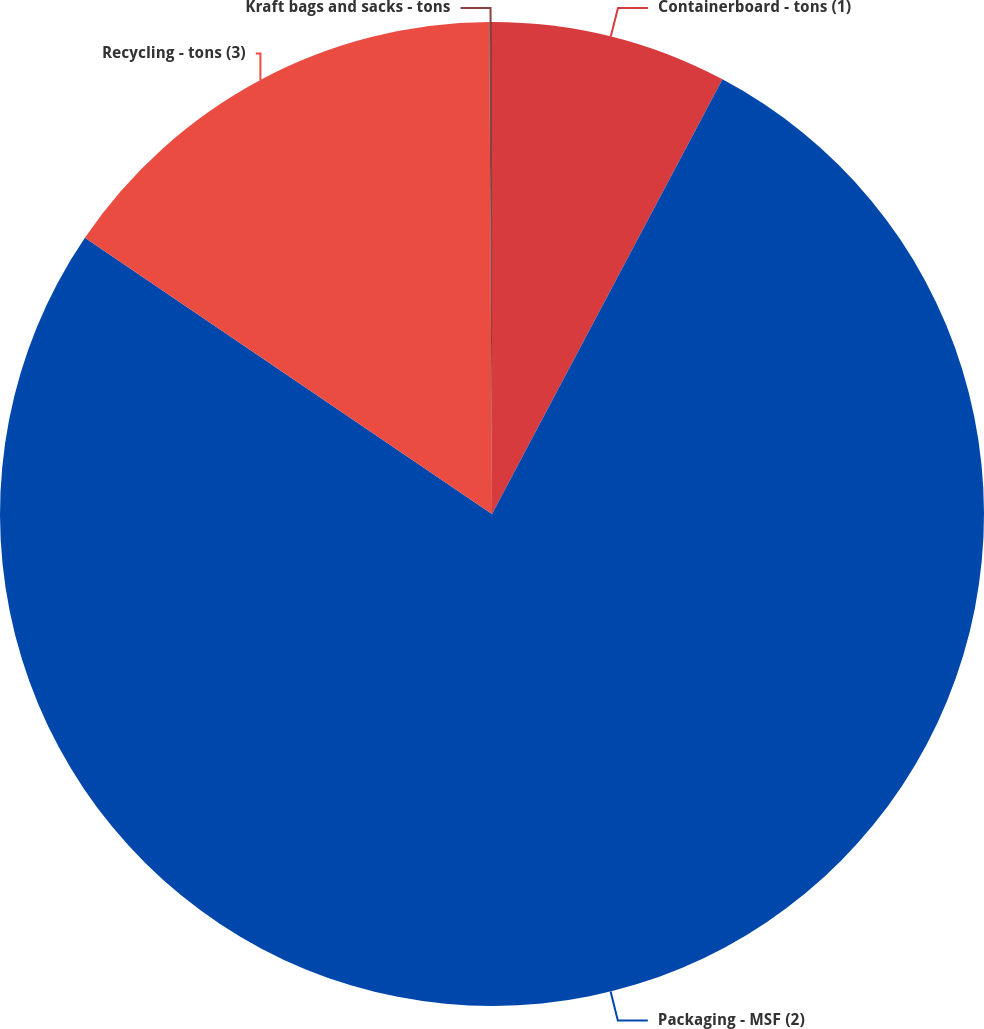Convert chart to OTSL. <chart><loc_0><loc_0><loc_500><loc_500><pie_chart><fcel>Containerboard - tons (1)<fcel>Packaging - MSF (2)<fcel>Recycling - tons (3)<fcel>Kraft bags and sacks - tons<nl><fcel>7.76%<fcel>76.73%<fcel>15.42%<fcel>0.09%<nl></chart> 